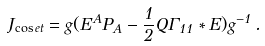Convert formula to latex. <formula><loc_0><loc_0><loc_500><loc_500>J _ { \cos e t } = g ( E ^ { A } P _ { A } - \frac { 1 } { 2 } Q \Gamma _ { 1 1 } * E ) g ^ { - 1 } \, .</formula> 